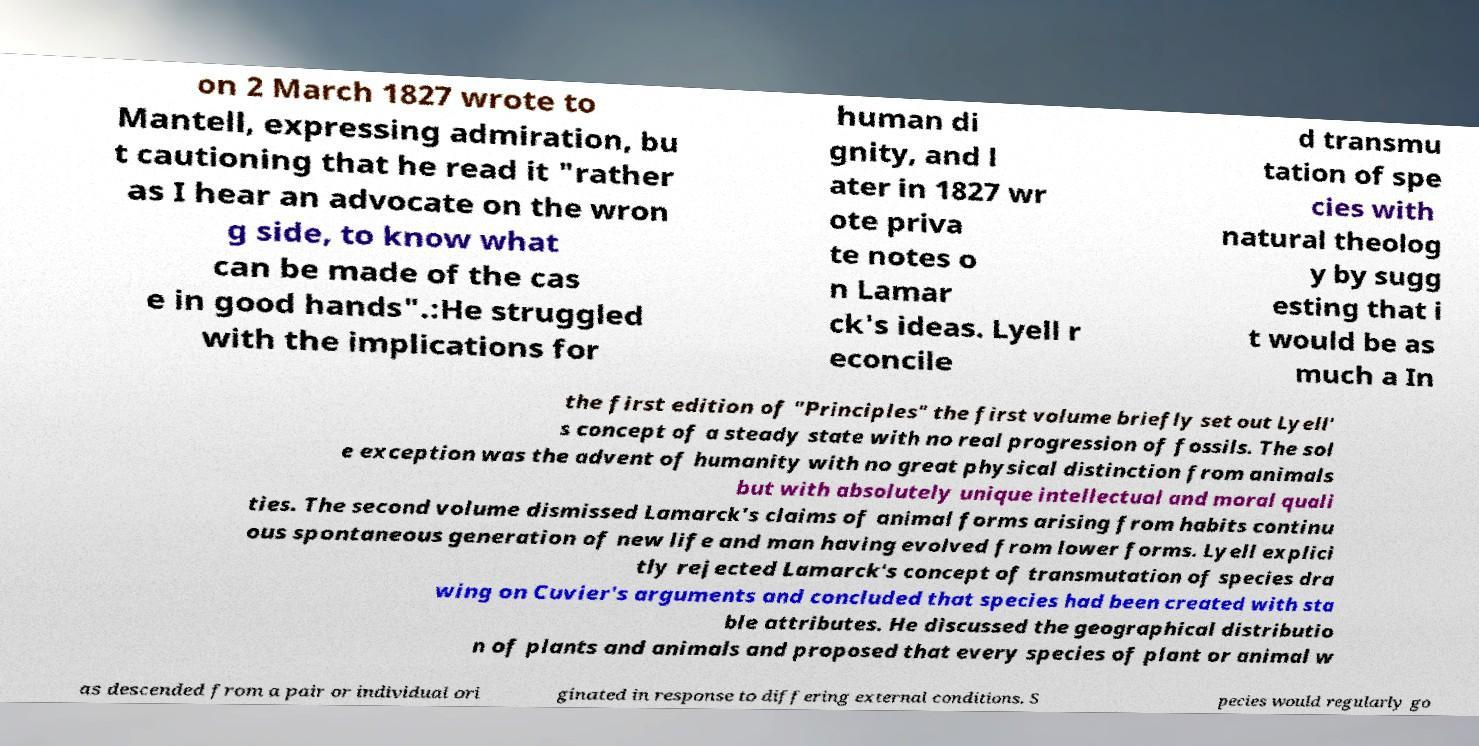Can you read and provide the text displayed in the image?This photo seems to have some interesting text. Can you extract and type it out for me? on 2 March 1827 wrote to Mantell, expressing admiration, bu t cautioning that he read it "rather as I hear an advocate on the wron g side, to know what can be made of the cas e in good hands".:He struggled with the implications for human di gnity, and l ater in 1827 wr ote priva te notes o n Lamar ck's ideas. Lyell r econcile d transmu tation of spe cies with natural theolog y by sugg esting that i t would be as much a In the first edition of "Principles" the first volume briefly set out Lyell' s concept of a steady state with no real progression of fossils. The sol e exception was the advent of humanity with no great physical distinction from animals but with absolutely unique intellectual and moral quali ties. The second volume dismissed Lamarck's claims of animal forms arising from habits continu ous spontaneous generation of new life and man having evolved from lower forms. Lyell explici tly rejected Lamarck's concept of transmutation of species dra wing on Cuvier's arguments and concluded that species had been created with sta ble attributes. He discussed the geographical distributio n of plants and animals and proposed that every species of plant or animal w as descended from a pair or individual ori ginated in response to differing external conditions. S pecies would regularly go 